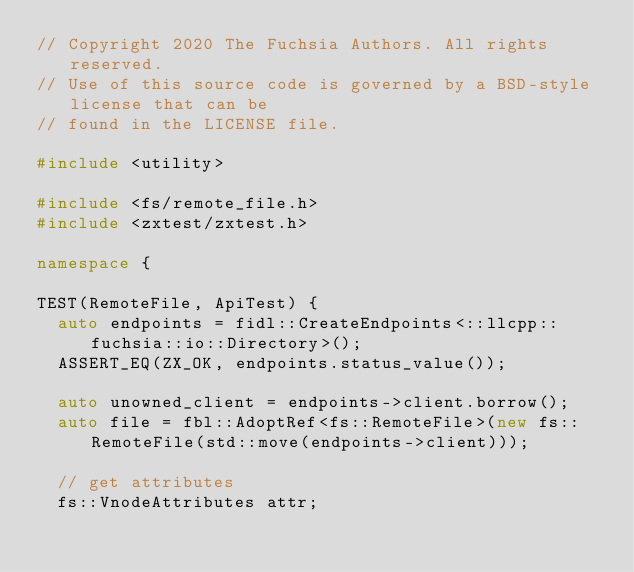Convert code to text. <code><loc_0><loc_0><loc_500><loc_500><_C++_>// Copyright 2020 The Fuchsia Authors. All rights reserved.
// Use of this source code is governed by a BSD-style license that can be
// found in the LICENSE file.

#include <utility>

#include <fs/remote_file.h>
#include <zxtest/zxtest.h>

namespace {

TEST(RemoteFile, ApiTest) {
  auto endpoints = fidl::CreateEndpoints<::llcpp::fuchsia::io::Directory>();
  ASSERT_EQ(ZX_OK, endpoints.status_value());

  auto unowned_client = endpoints->client.borrow();
  auto file = fbl::AdoptRef<fs::RemoteFile>(new fs::RemoteFile(std::move(endpoints->client)));

  // get attributes
  fs::VnodeAttributes attr;</code> 